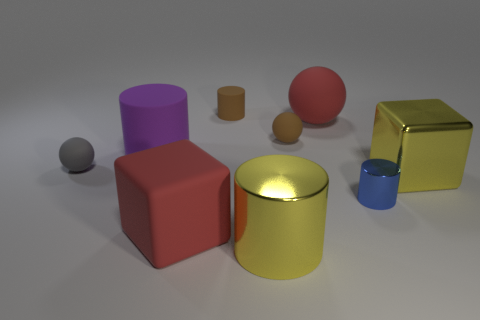There is a big yellow thing that is the same shape as the small blue object; what is it made of? The big yellow thing, sharing its cylindrical shape with the smaller blue object, appears to be made of a glossy material indicative of metal, possibly a reflective gold-like finish suggesting it might be brass or a similarly colored metal alloy. 